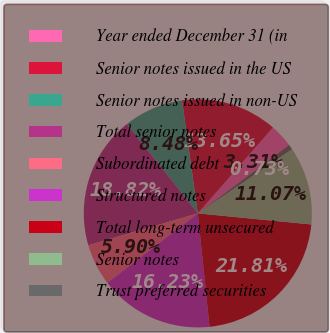<chart> <loc_0><loc_0><loc_500><loc_500><pie_chart><fcel>Year ended December 31 (in<fcel>Senior notes issued in the US<fcel>Senior notes issued in non-US<fcel>Total senior notes<fcel>Subordinated debt<fcel>Structured notes<fcel>Total long-term unsecured<fcel>Senior notes<fcel>Trust preferred securities<nl><fcel>3.31%<fcel>13.65%<fcel>8.48%<fcel>18.82%<fcel>5.9%<fcel>16.23%<fcel>21.81%<fcel>11.07%<fcel>0.73%<nl></chart> 